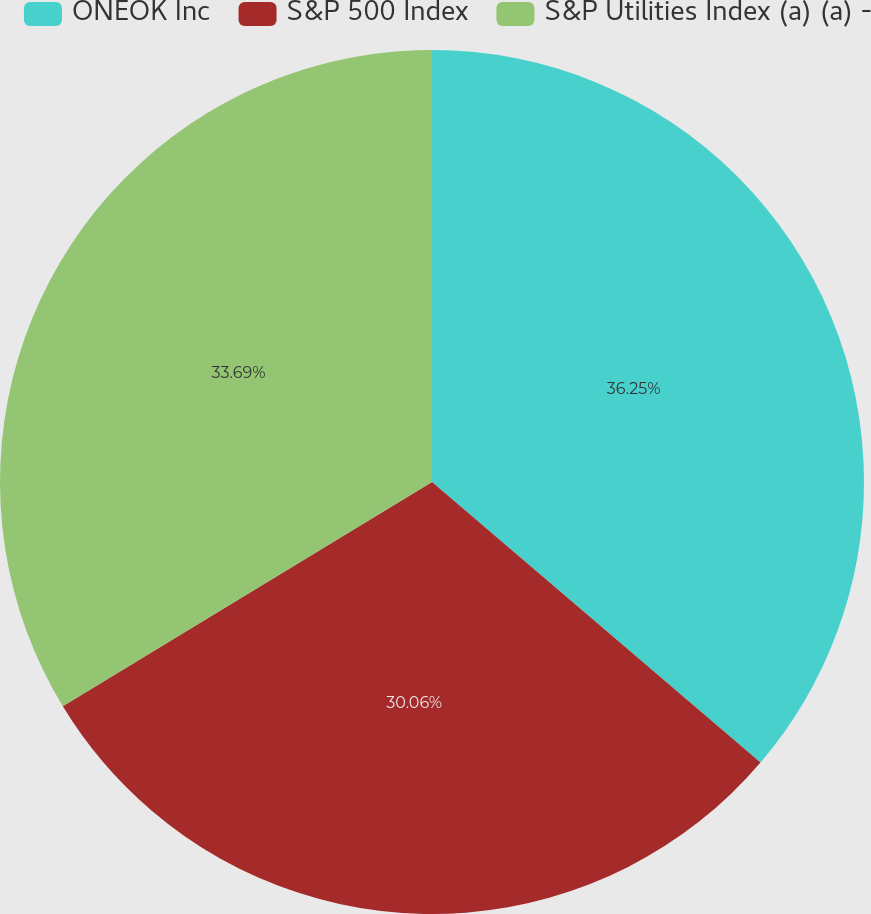Convert chart. <chart><loc_0><loc_0><loc_500><loc_500><pie_chart><fcel>ONEOK Inc<fcel>S&P 500 Index<fcel>S&P Utilities Index (a) (a) -<nl><fcel>36.25%<fcel>30.06%<fcel>33.69%<nl></chart> 